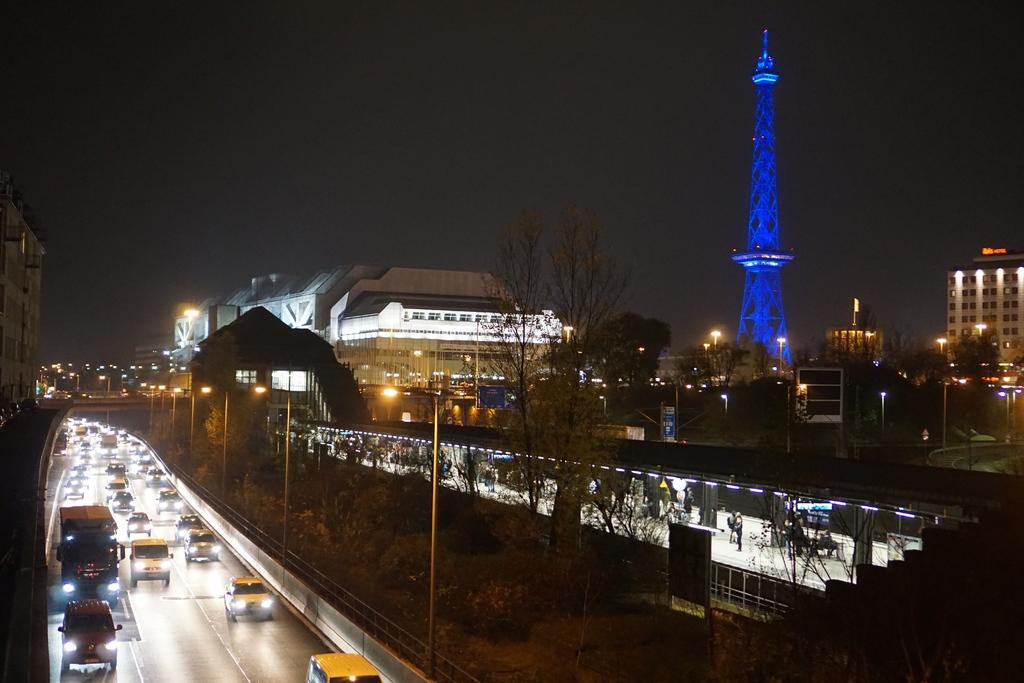What is visible at the top of the image? The sky is visible at the top of the image. What can be seen on the road in the image? There are vehicles on the road in the image. What type of structures are present in the image? There are buildings in the image. What other natural elements can be seen in the image? There are trees in the image. What stands out as a tall structure in the image? There is a tower in the image. How many dogs are present in the image? There are no dogs present in the image. What unit of measurement is used to determine the height of the tower in the image? The provided facts do not mention any specific unit of measurement for the tower's height. 